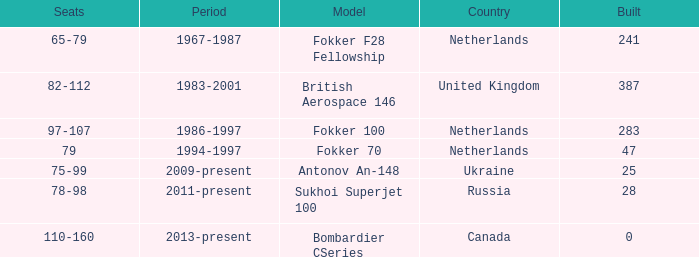How many cabins were built in the time between 1967-1987? 241.0. 